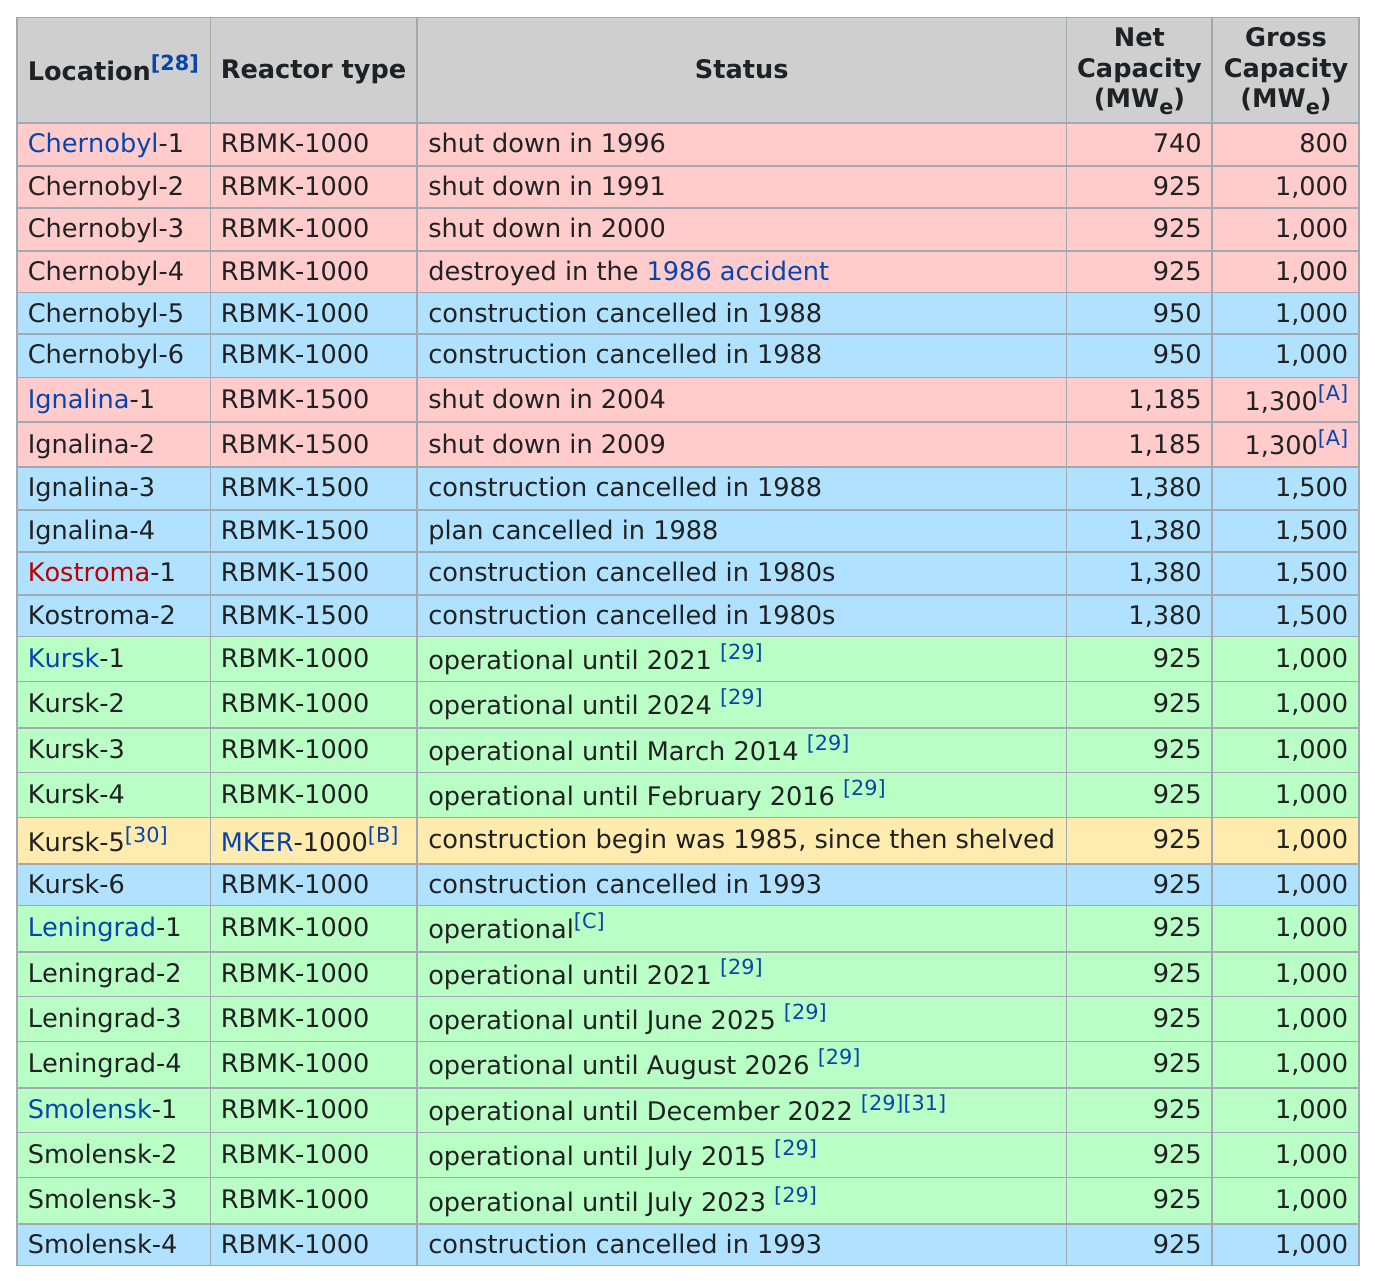Give some essential details in this illustration. The location with the most reactors that were shut down was Chernobyl. Kostroma had construction cancelled in the 1980s. The Chernobyl-1 nuclear power plant was first shut down in 1996. Kostroma is the location that is listed the least on this chart. The Leningrad-4 reactor is the only operational reactor until August 2026. 